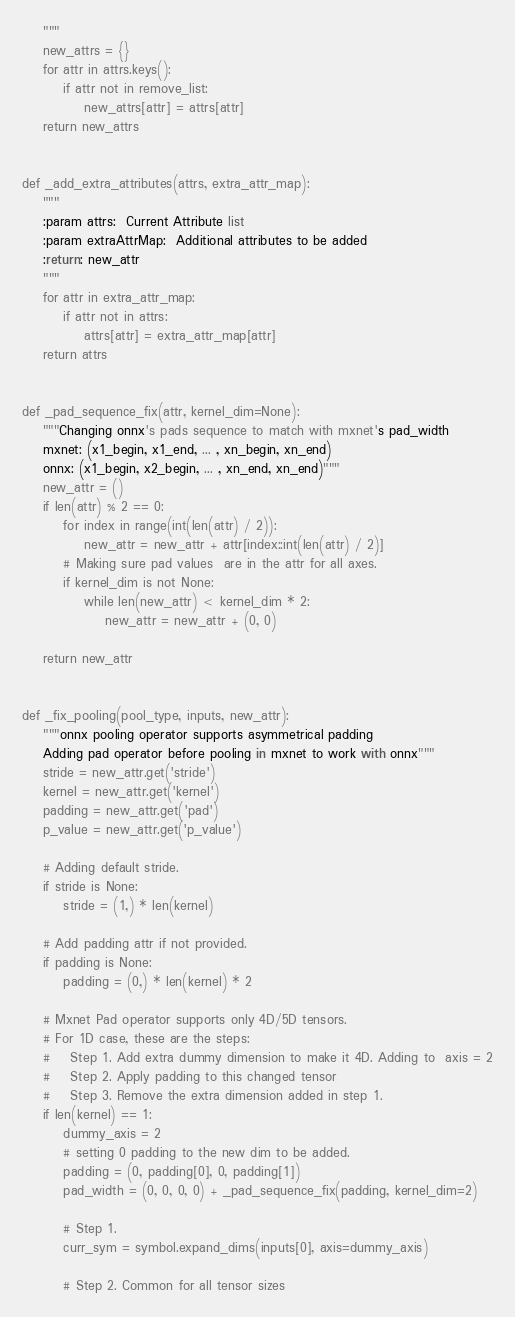<code> <loc_0><loc_0><loc_500><loc_500><_Python_>    """
    new_attrs = {}
    for attr in attrs.keys():
        if attr not in remove_list:
            new_attrs[attr] = attrs[attr]
    return new_attrs


def _add_extra_attributes(attrs, extra_attr_map):
    """
    :param attrs:  Current Attribute list
    :param extraAttrMap:  Additional attributes to be added
    :return: new_attr
    """
    for attr in extra_attr_map:
        if attr not in attrs:
            attrs[attr] = extra_attr_map[attr]
    return attrs


def _pad_sequence_fix(attr, kernel_dim=None):
    """Changing onnx's pads sequence to match with mxnet's pad_width
    mxnet: (x1_begin, x1_end, ... , xn_begin, xn_end)
    onnx: (x1_begin, x2_begin, ... , xn_end, xn_end)"""
    new_attr = ()
    if len(attr) % 2 == 0:
        for index in range(int(len(attr) / 2)):
            new_attr = new_attr + attr[index::int(len(attr) / 2)]
        # Making sure pad values  are in the attr for all axes.
        if kernel_dim is not None:
            while len(new_attr) < kernel_dim * 2:
                new_attr = new_attr + (0, 0)

    return new_attr


def _fix_pooling(pool_type, inputs, new_attr):
    """onnx pooling operator supports asymmetrical padding
    Adding pad operator before pooling in mxnet to work with onnx"""
    stride = new_attr.get('stride')
    kernel = new_attr.get('kernel')
    padding = new_attr.get('pad')
    p_value = new_attr.get('p_value')

    # Adding default stride.
    if stride is None:
        stride = (1,) * len(kernel)

    # Add padding attr if not provided.
    if padding is None:
        padding = (0,) * len(kernel) * 2

    # Mxnet Pad operator supports only 4D/5D tensors.
    # For 1D case, these are the steps:
    #    Step 1. Add extra dummy dimension to make it 4D. Adding to  axis = 2
    #    Step 2. Apply padding to this changed tensor
    #    Step 3. Remove the extra dimension added in step 1.
    if len(kernel) == 1:
        dummy_axis = 2
        # setting 0 padding to the new dim to be added.
        padding = (0, padding[0], 0, padding[1])
        pad_width = (0, 0, 0, 0) + _pad_sequence_fix(padding, kernel_dim=2)

        # Step 1.
        curr_sym = symbol.expand_dims(inputs[0], axis=dummy_axis)

        # Step 2. Common for all tensor sizes</code> 